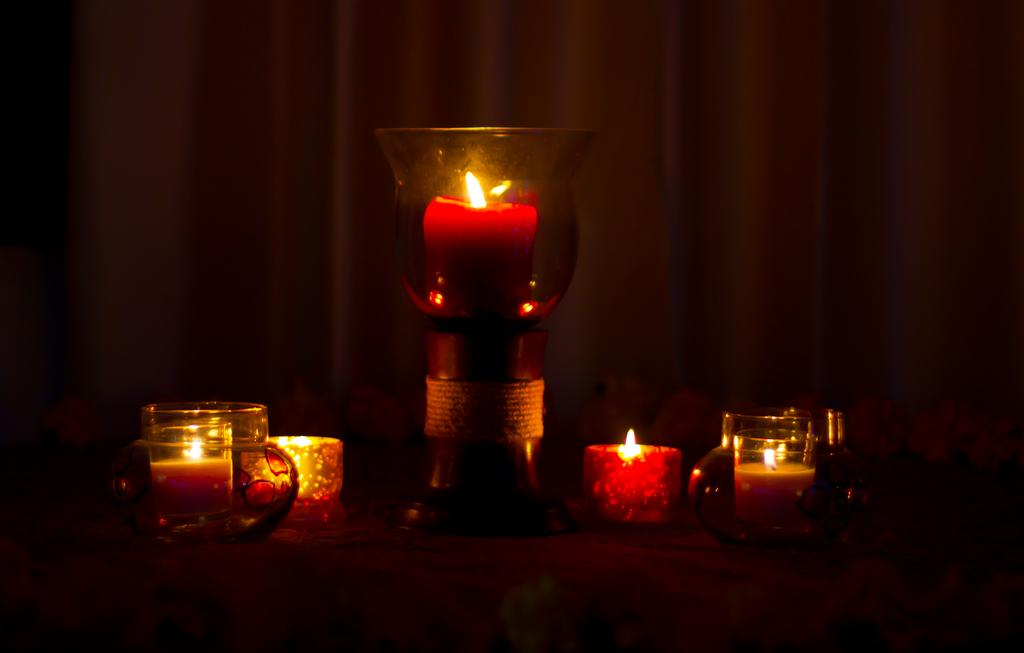What is located in the foreground of the image? There is a table in the foreground of the image. What items can be seen on the table? Jars and candles are present on the table. What is visible in the background of the image? There is a curtain in the background of the image. What time of day was the image taken? The image was taken during the night. What type of wood is used to make the candles in the image? There is no information about the type of wood used to make the candles, as the image only shows the presence of candles and not their construction. 